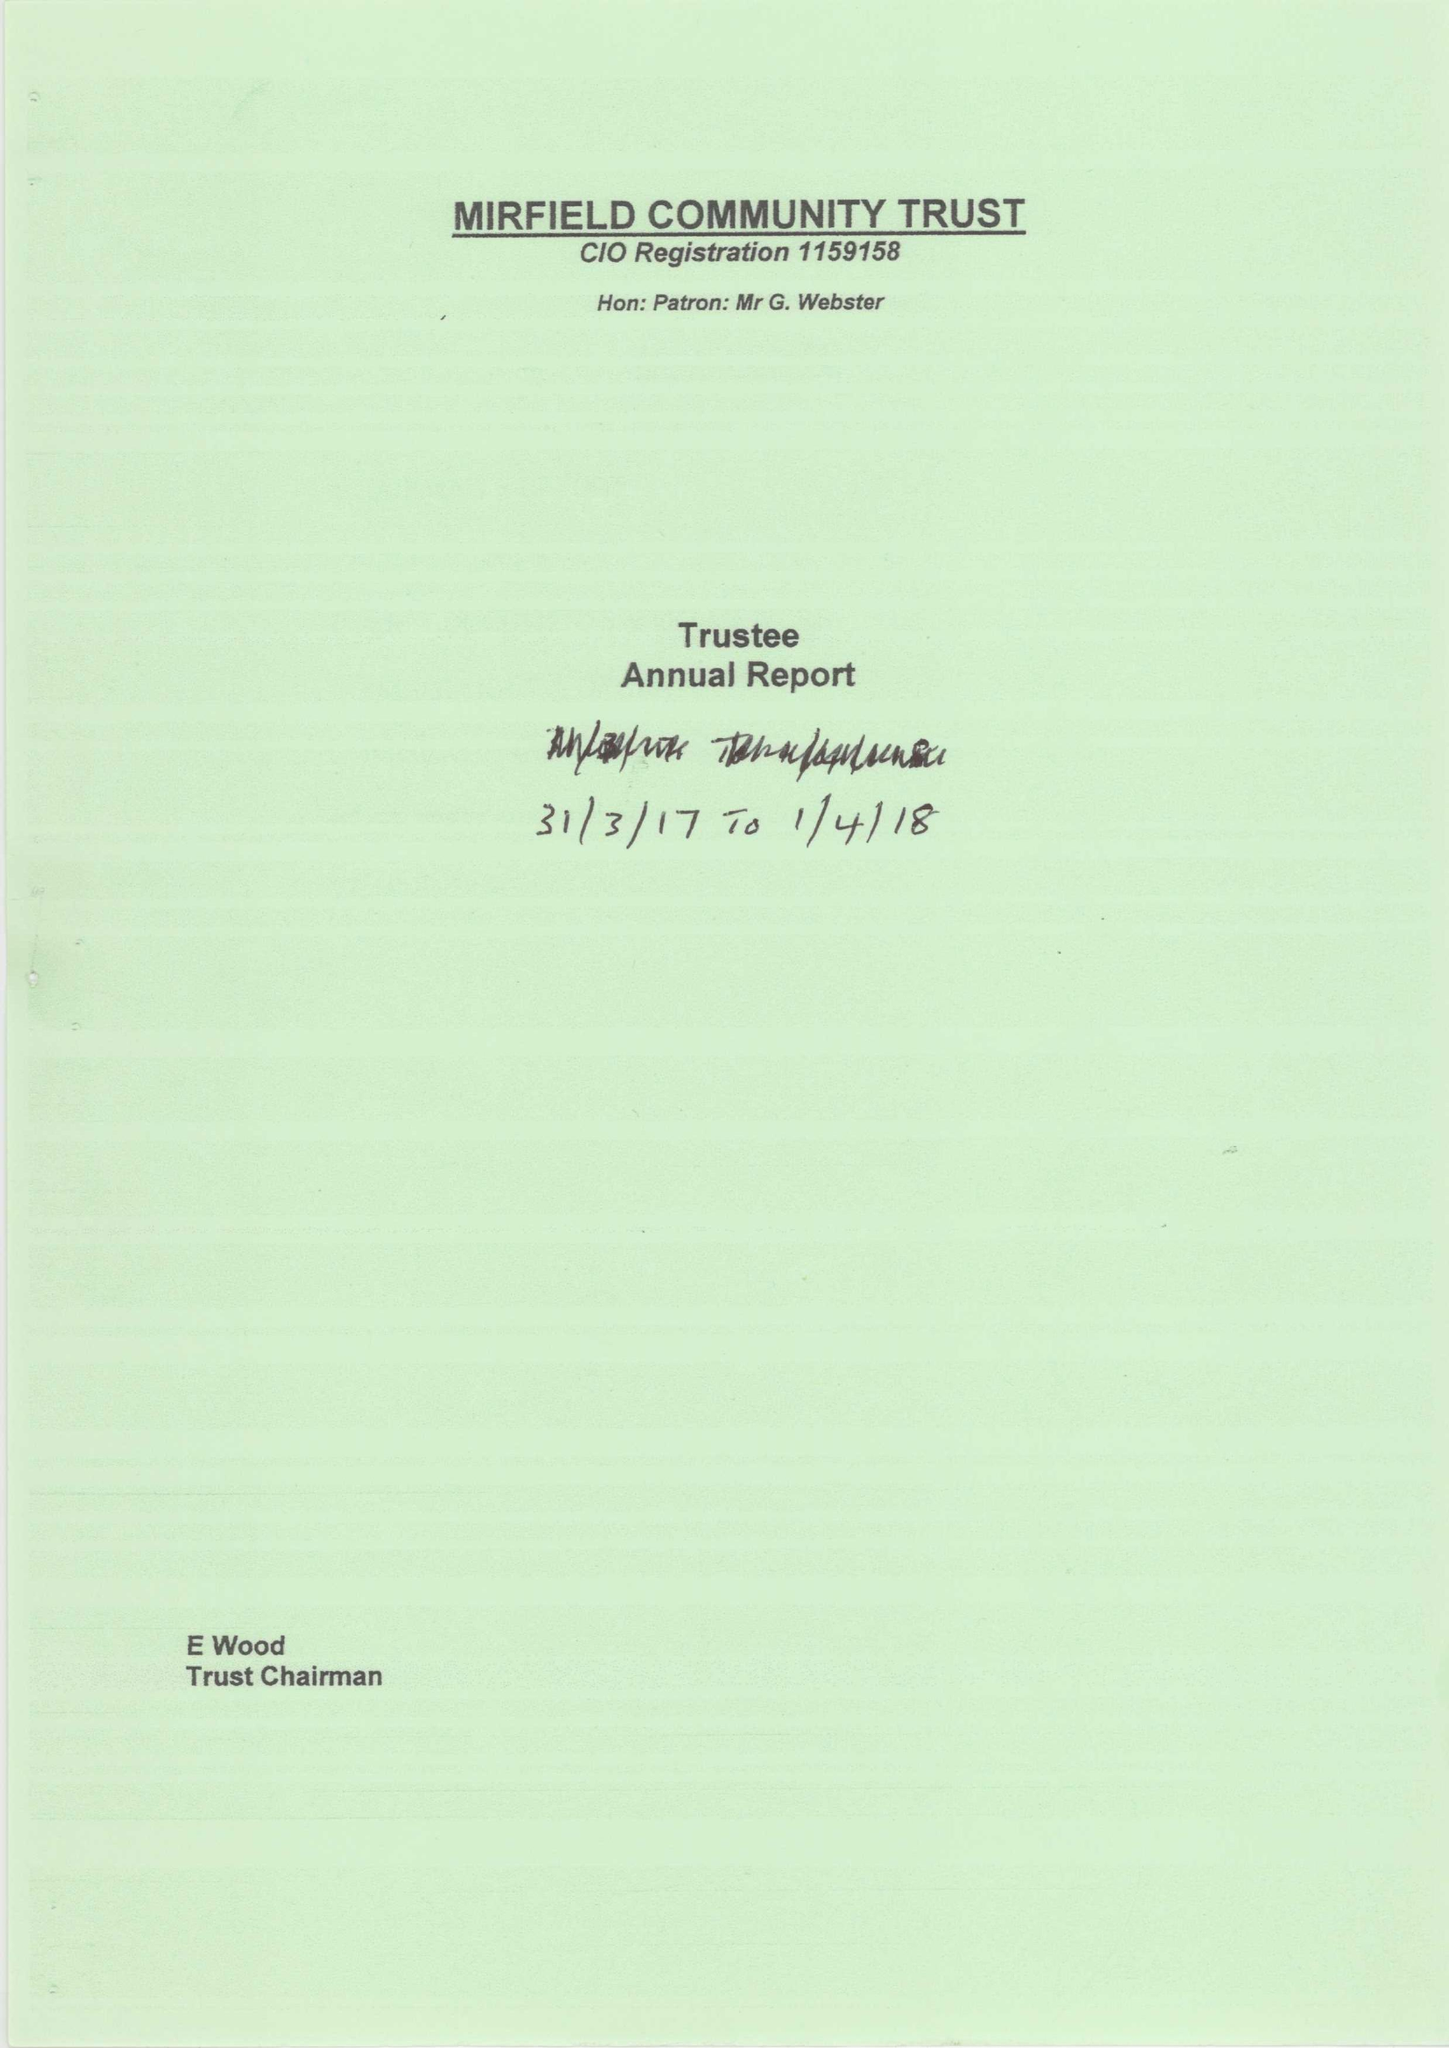What is the value for the address__street_line?
Answer the question using a single word or phrase. 30 VICARAGE MEADOW 